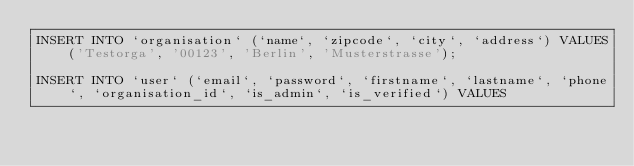Convert code to text. <code><loc_0><loc_0><loc_500><loc_500><_SQL_>INSERT INTO `organisation` (`name`, `zipcode`, `city`, `address`) VALUES
    ('Testorga', '00123', 'Berlin', 'Musterstrasse');

INSERT INTO `user` (`email`, `password`, `firstname`, `lastname`, `phone`, `organisation_id`, `is_admin`, `is_verified`) VALUES</code> 